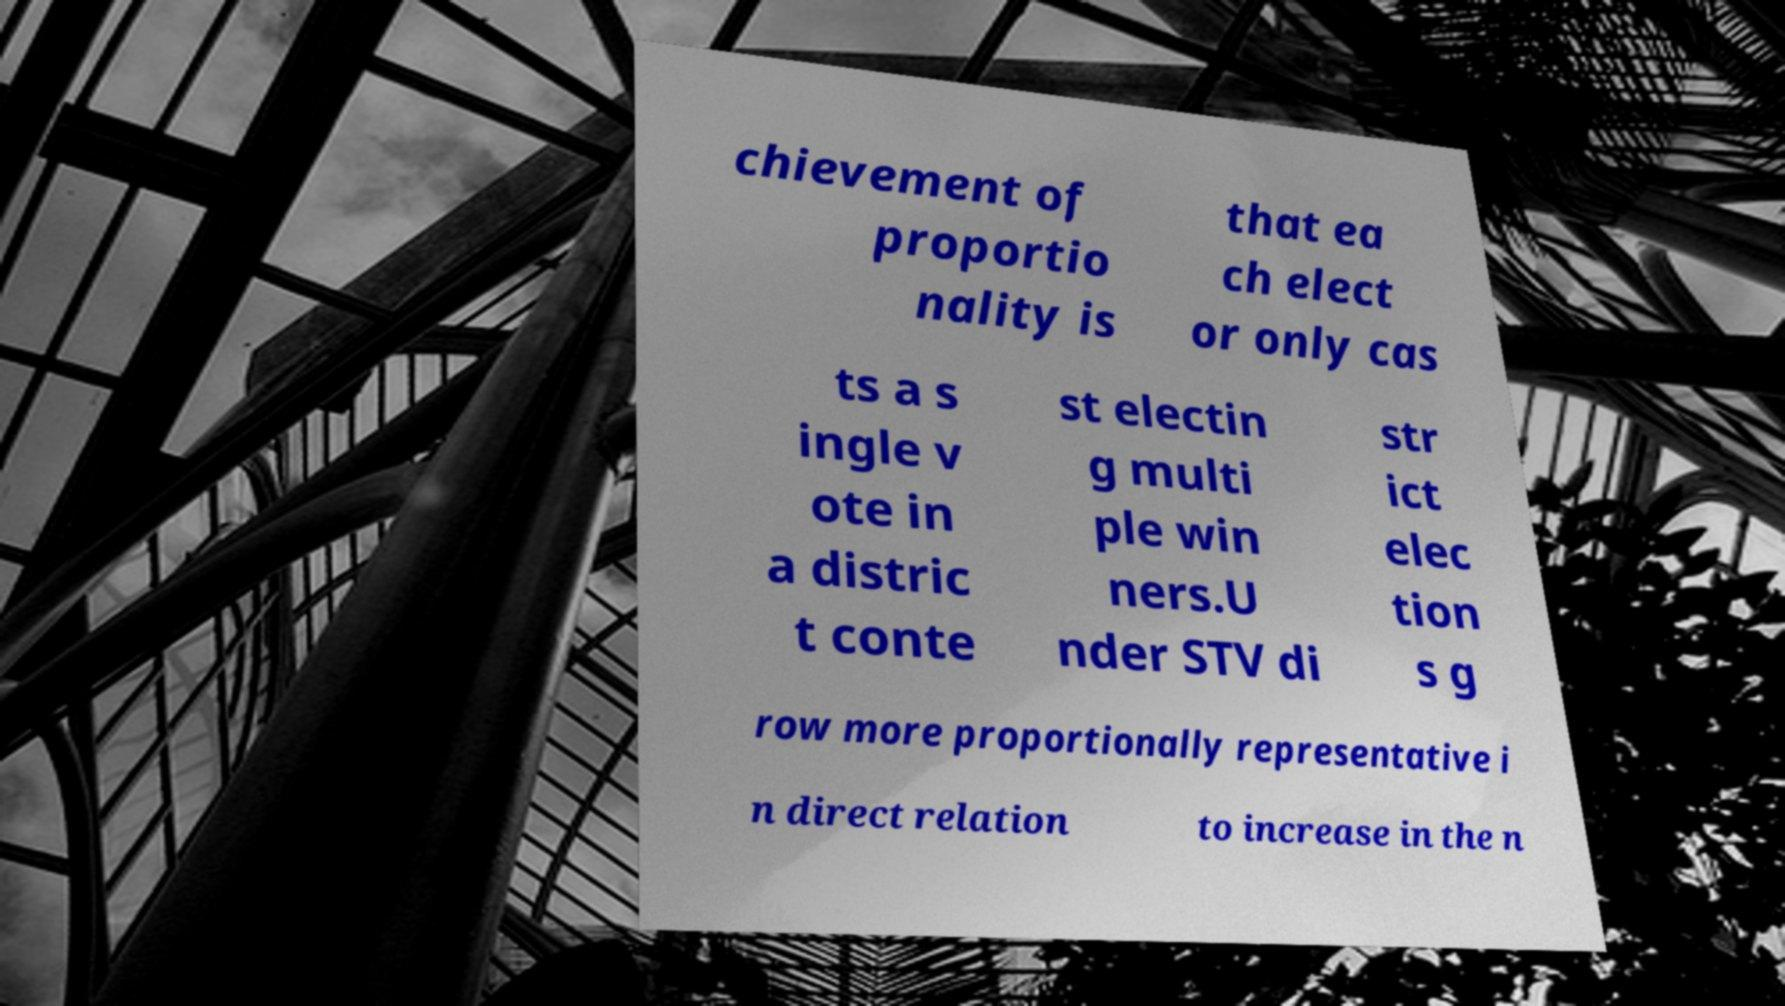Could you extract and type out the text from this image? chievement of proportio nality is that ea ch elect or only cas ts a s ingle v ote in a distric t conte st electin g multi ple win ners.U nder STV di str ict elec tion s g row more proportionally representative i n direct relation to increase in the n 